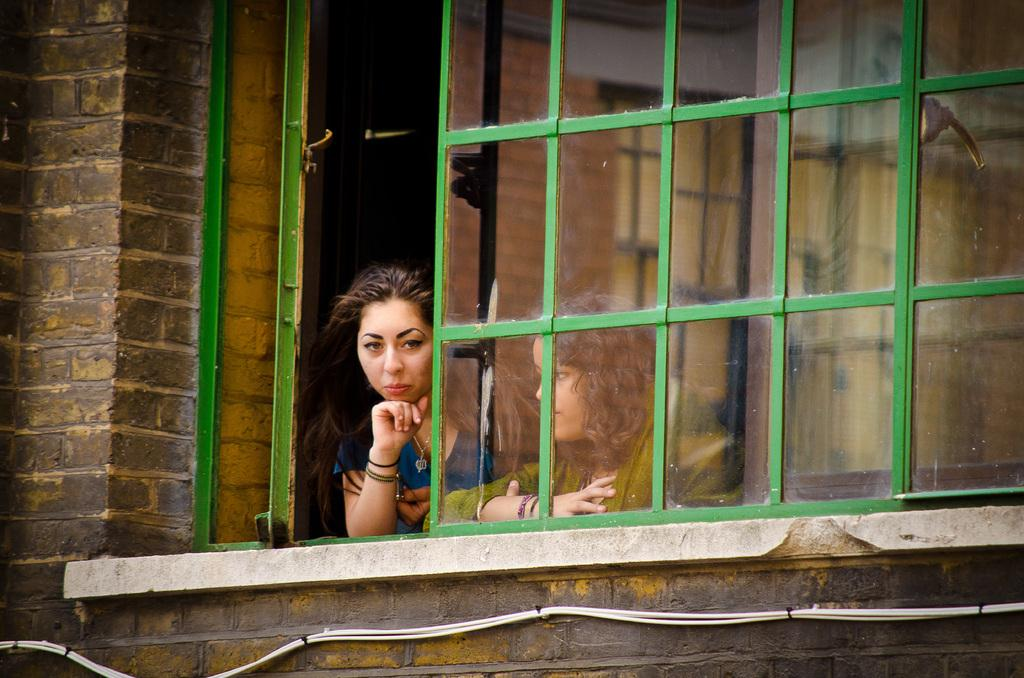How many people are in the image? There are two people in the image. What are the people doing in the image? The two people are standing near a window. What can be seen in the background of the image? There is a wall in the image. Are there any other objects or features visible in the image? Yes, there are wires visible in the image. Can you describe the pain experienced by the people in the image? There is no indication of pain or discomfort in the image; the two people are simply standing near a window. What type of tongue can be seen in the image? There is no tongue present in the image. 